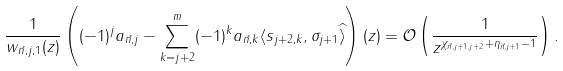<formula> <loc_0><loc_0><loc_500><loc_500>\frac { 1 } { w _ { \vec { n } , j , 1 } ( z ) } \left ( ( - 1 ) ^ { j } a _ { \vec { n } , j } - \sum _ { k = j + 2 } ^ { m } ( - 1 ) ^ { k } a _ { \vec { n } , k } \langle s _ { j + 2 , k } , \sigma _ { j + 1 } \widehat { \rangle } \right ) ( z ) = \mathcal { O } \left ( \frac { 1 } { z ^ { \chi _ { \vec { n } , j + 1 , j + 2 } + \eta _ { \vec { n } , j + 1 } - 1 } } \right ) .</formula> 